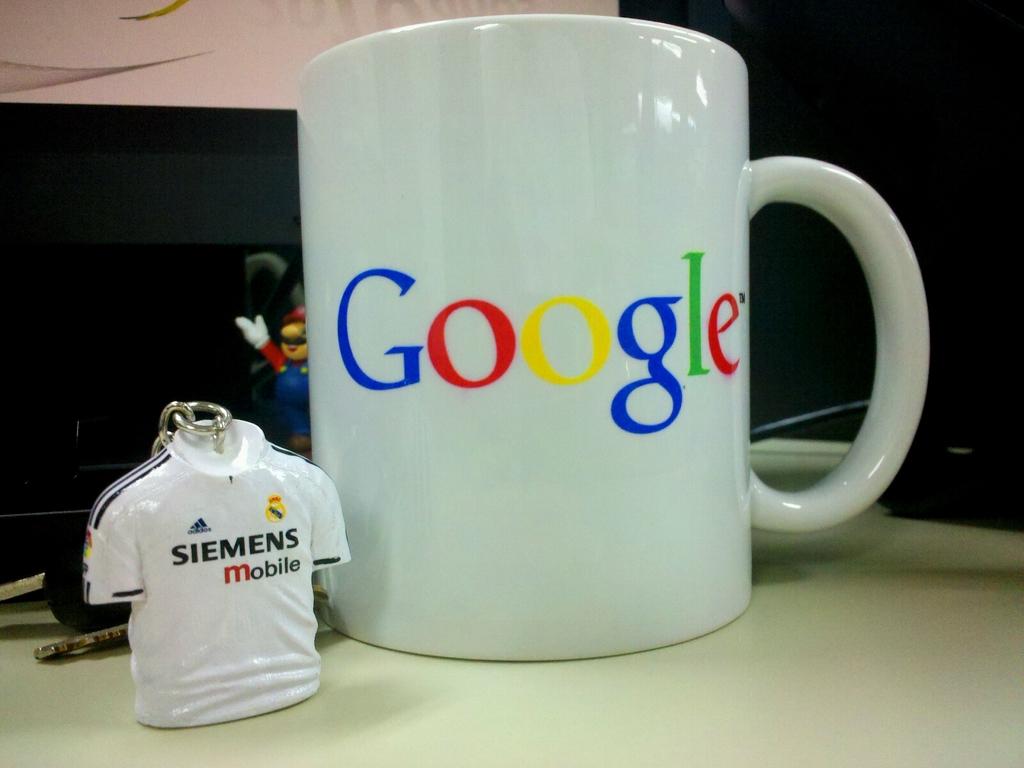What does the keychain say?
Your answer should be compact. Siemens mobile. What company's logo is on the white mug?
Your answer should be very brief. Google. 